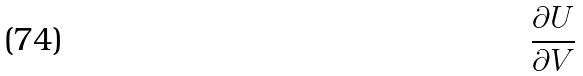<formula> <loc_0><loc_0><loc_500><loc_500>\frac { \partial U } { \partial V }</formula> 